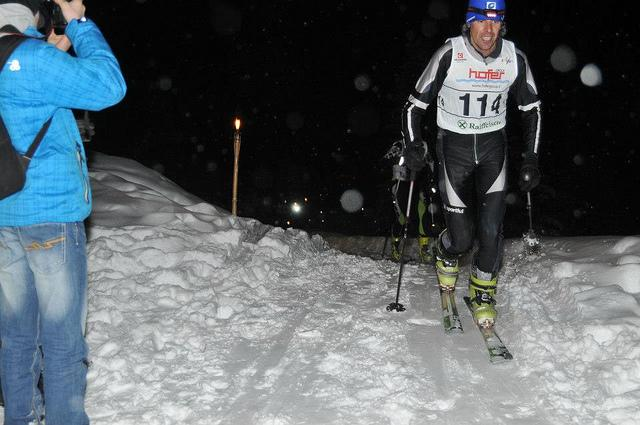What is that light in the distance called? torch 